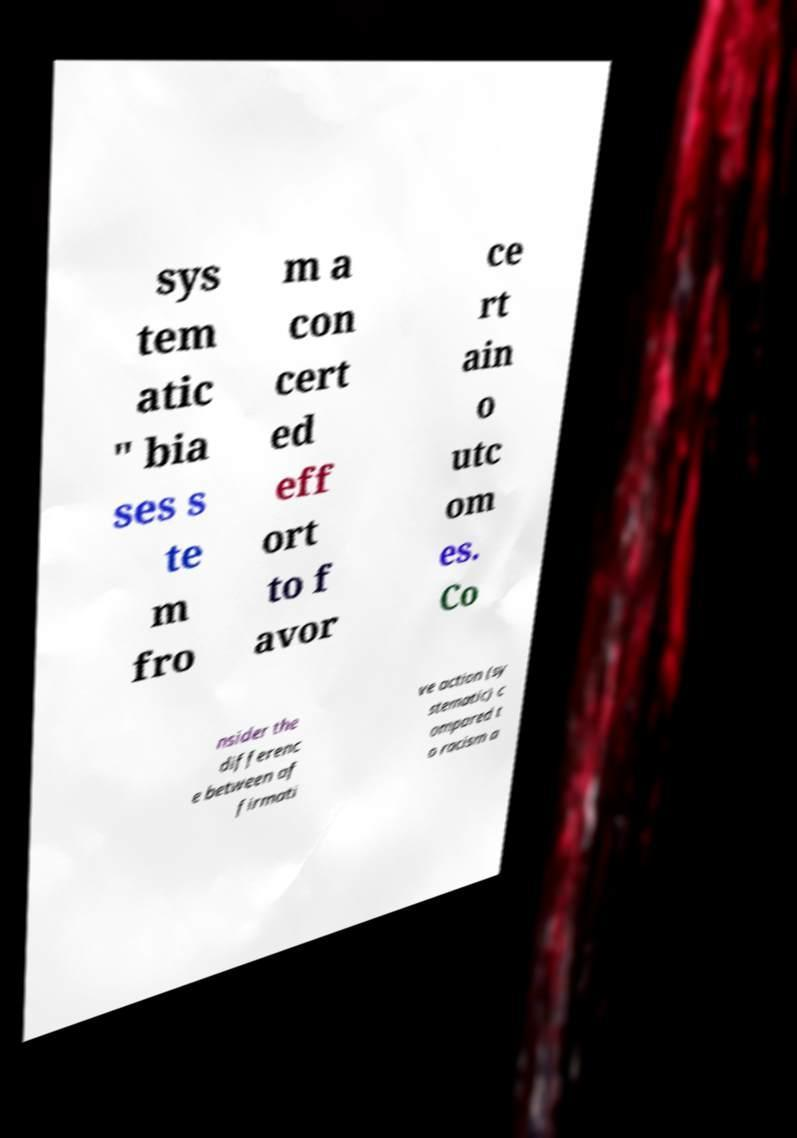Could you extract and type out the text from this image? sys tem atic " bia ses s te m fro m a con cert ed eff ort to f avor ce rt ain o utc om es. Co nsider the differenc e between af firmati ve action (sy stematic) c ompared t o racism a 